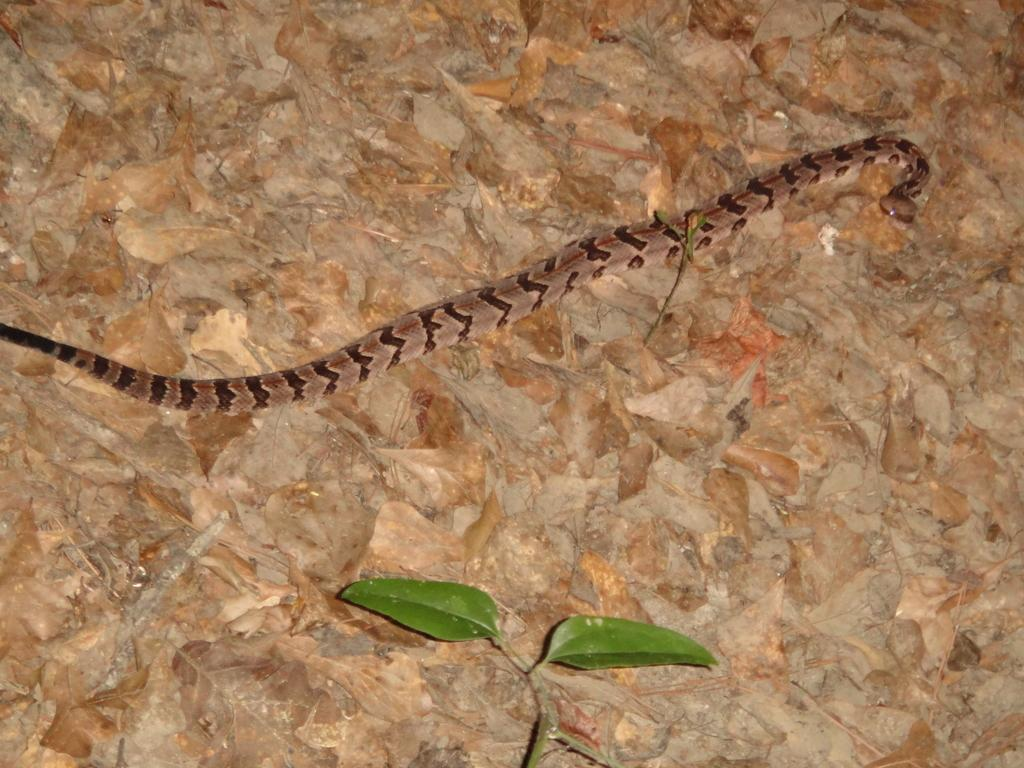What type of animal is in the image? There is a snake in the image. What other objects can be seen in the image? There are two green leaves in the image. What type of arch can be seen in the image? There is no arch present in the image. What type of vacation is being depicted in the image? The image does not depict a vacation; it features a snake and green leaves. 